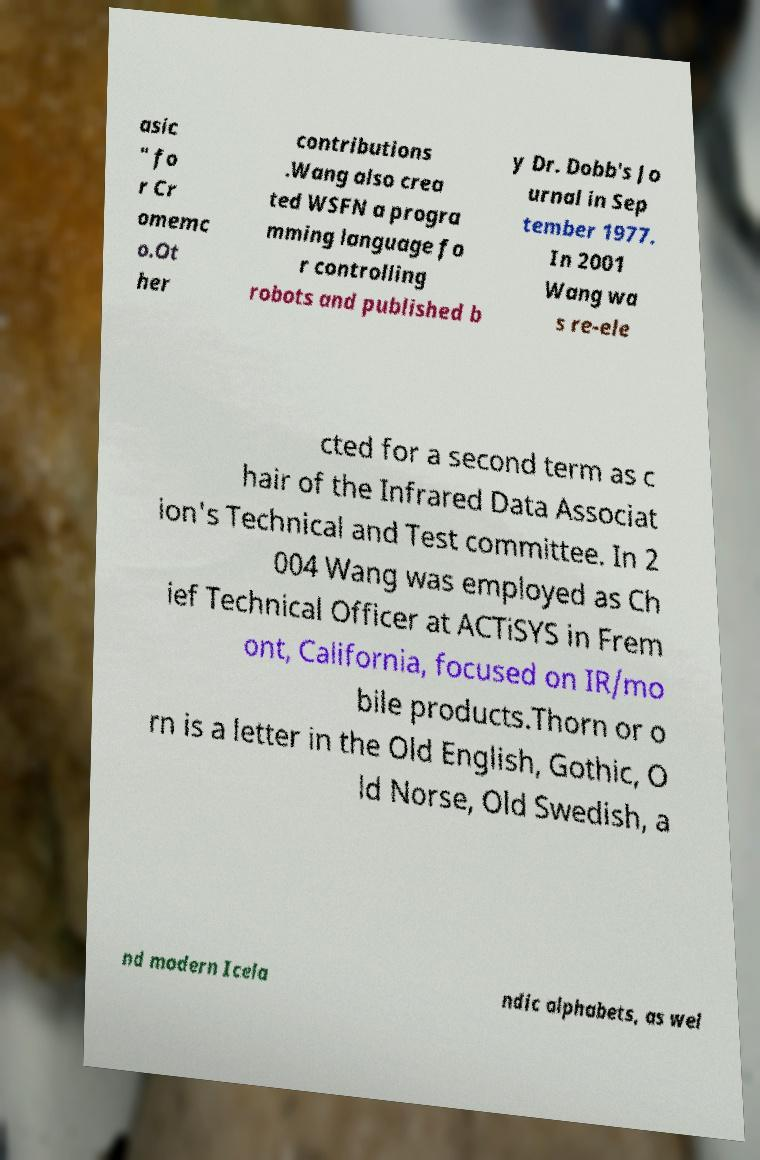Please identify and transcribe the text found in this image. asic " fo r Cr omemc o.Ot her contributions .Wang also crea ted WSFN a progra mming language fo r controlling robots and published b y Dr. Dobb's Jo urnal in Sep tember 1977. In 2001 Wang wa s re-ele cted for a second term as c hair of the Infrared Data Associat ion's Technical and Test committee. In 2 004 Wang was employed as Ch ief Technical Officer at ACTiSYS in Frem ont, California, focused on IR/mo bile products.Thorn or o rn is a letter in the Old English, Gothic, O ld Norse, Old Swedish, a nd modern Icela ndic alphabets, as wel 